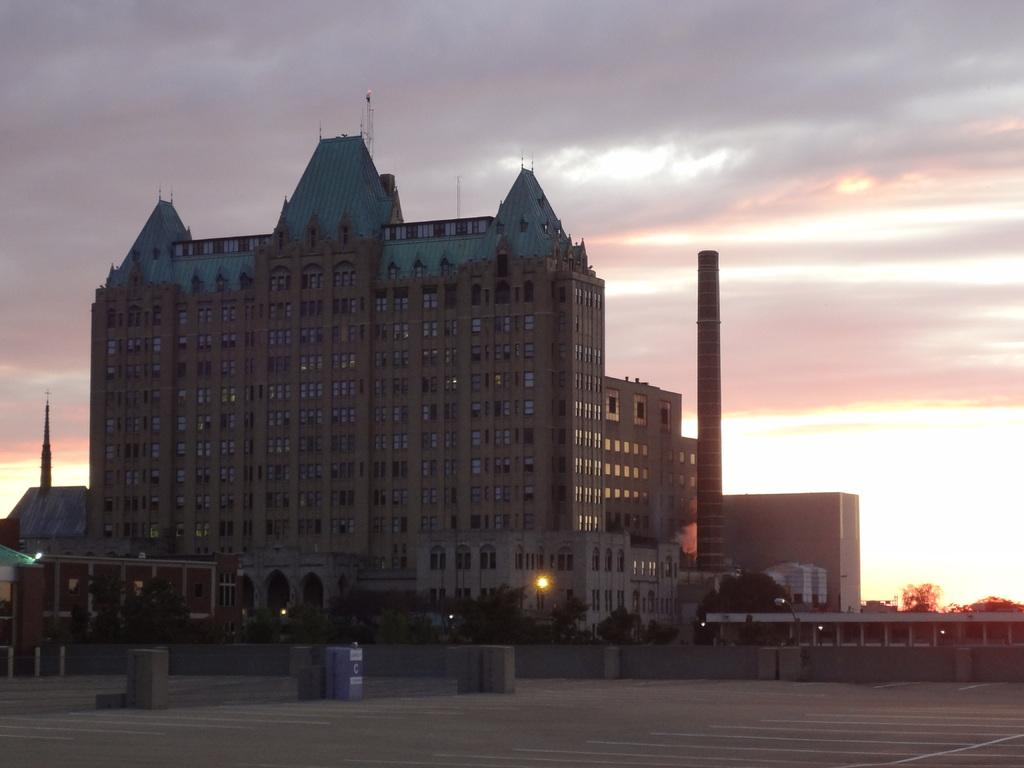What type of building is in the image? There is a big brown building with many windows in the image. What is located beside the building? There is a pipe pole beside the building. What can be seen in the front bottom area of the image? There are trees and an open area in the front bottom area of the image. What type of camp can be seen in the image? There is no camp present in the image; it features a big brown building with many windows, a pipe pole, trees, and an open area. 